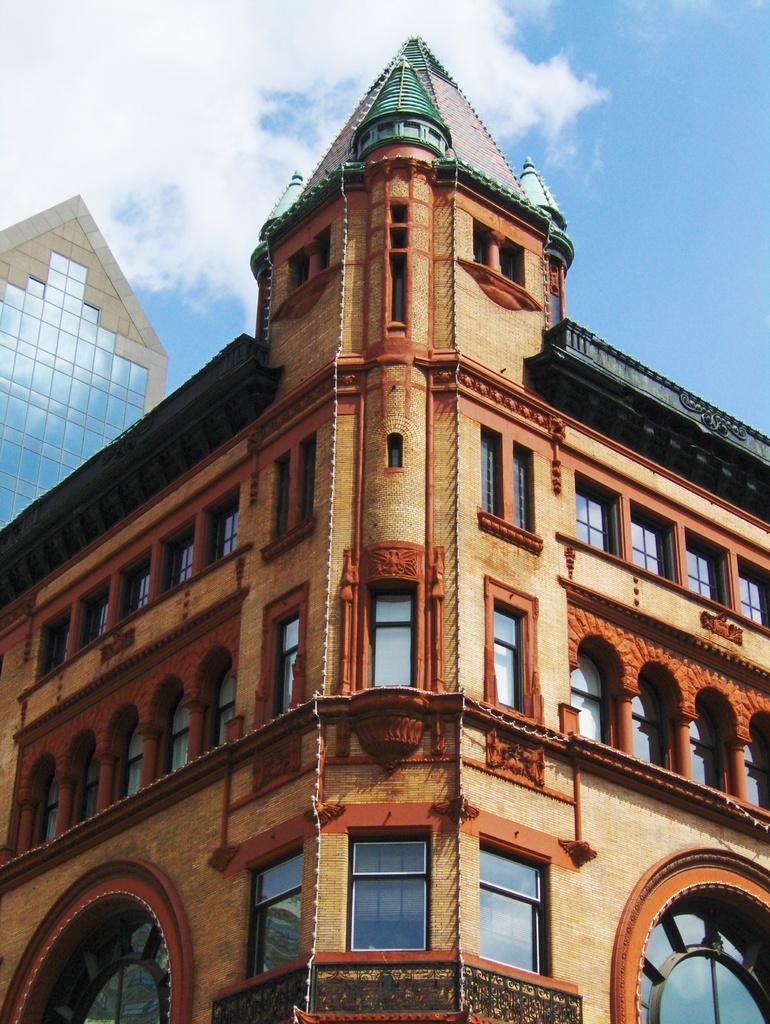Can you describe this image briefly? In this picture we can see a building, there is the sky and clouds at the top of the picture, we can see windows and glasses of this building. 